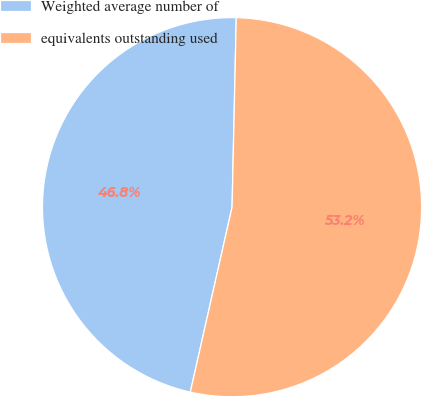<chart> <loc_0><loc_0><loc_500><loc_500><pie_chart><fcel>Weighted average number of<fcel>equivalents outstanding used<nl><fcel>46.82%<fcel>53.18%<nl></chart> 